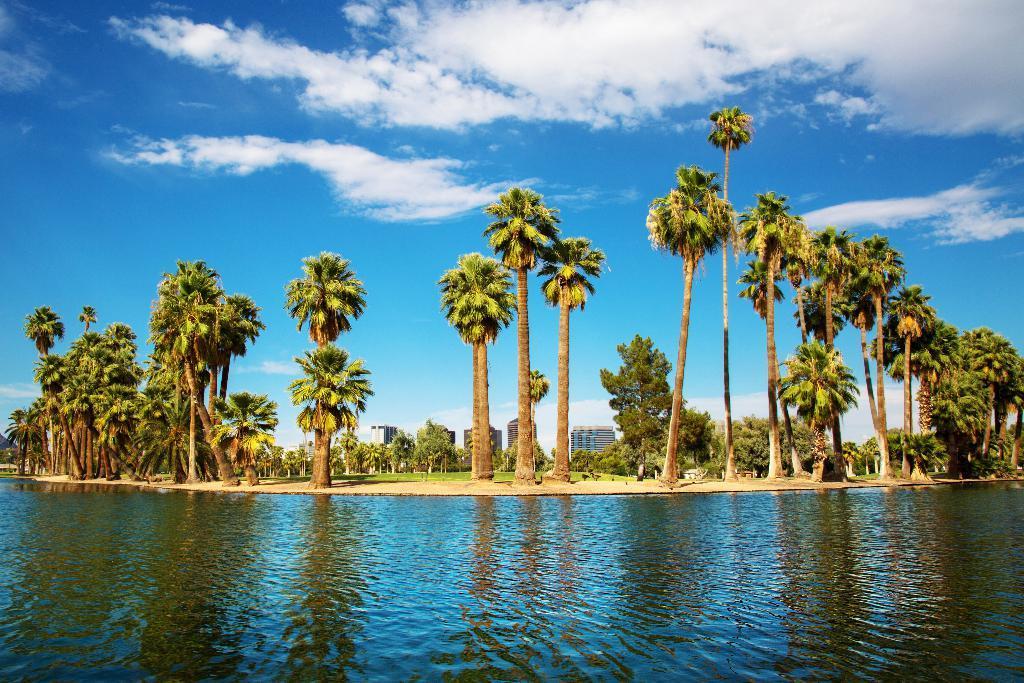Please provide a concise description of this image. At the bottom of this image, there is water. In the background, there are trees, buildings and grass on the ground and there are clouds in the blue sky. 